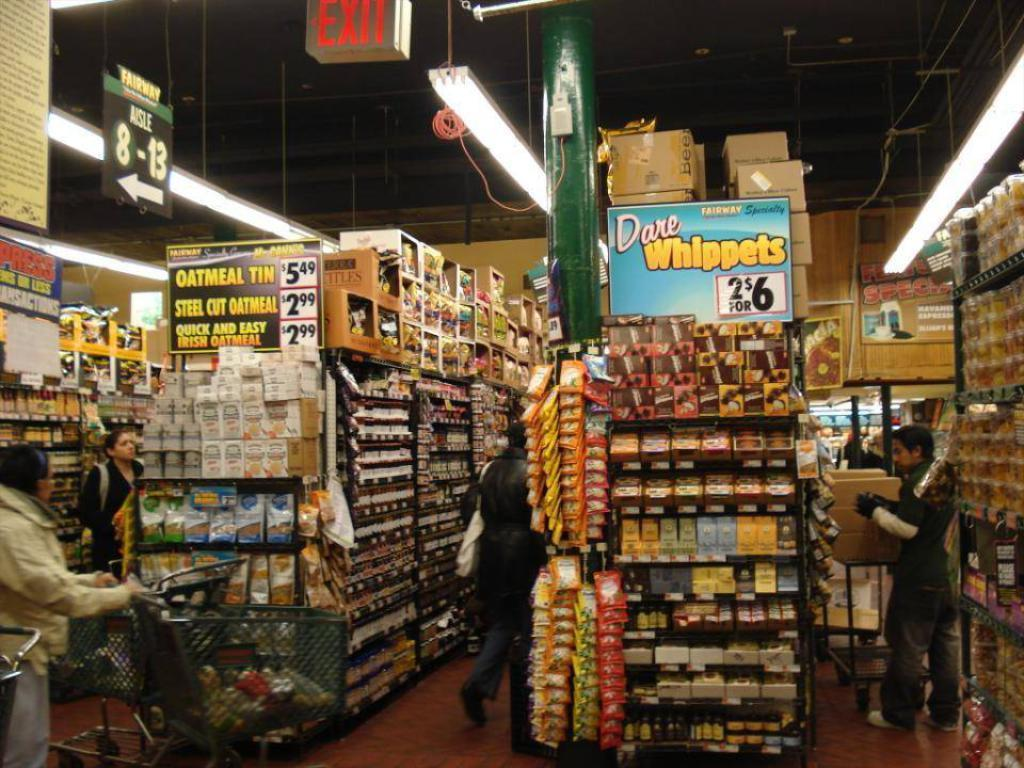Provide a one-sentence caption for the provided image. Grocery store with a large variety of goods Dare Wippets are two for six dollars. 